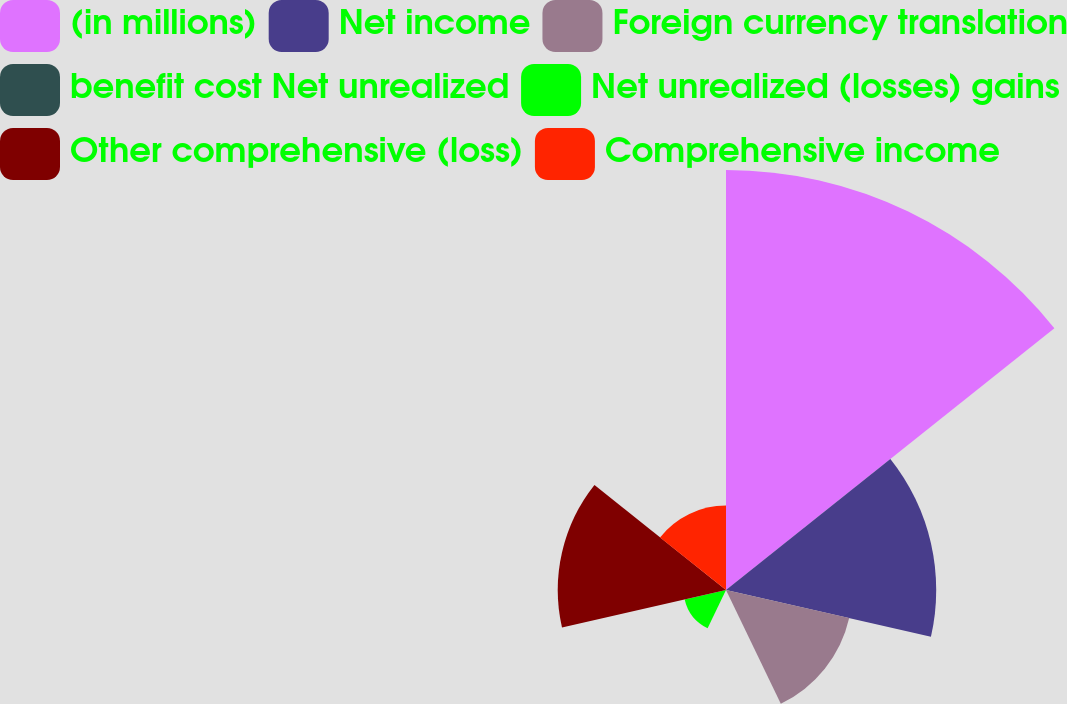Convert chart. <chart><loc_0><loc_0><loc_500><loc_500><pie_chart><fcel>(in millions)<fcel>Net income<fcel>Foreign currency translation<fcel>benefit cost Net unrealized<fcel>Net unrealized (losses) gains<fcel>Other comprehensive (loss)<fcel>Comprehensive income<nl><fcel>39.92%<fcel>19.98%<fcel>12.01%<fcel>0.04%<fcel>4.03%<fcel>15.99%<fcel>8.02%<nl></chart> 